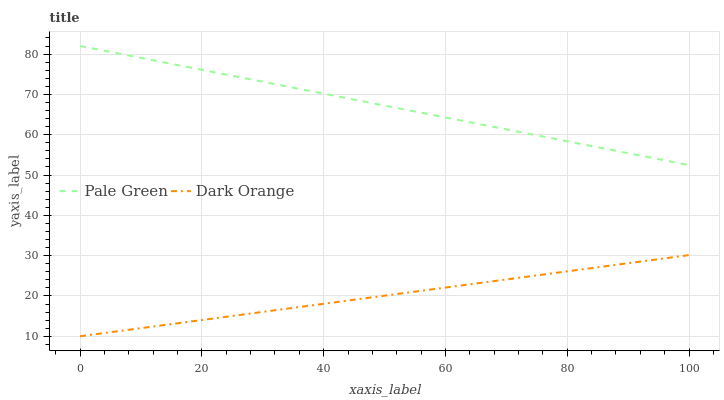Does Dark Orange have the minimum area under the curve?
Answer yes or no. Yes. Does Pale Green have the maximum area under the curve?
Answer yes or no. Yes. Does Pale Green have the minimum area under the curve?
Answer yes or no. No. Is Dark Orange the smoothest?
Answer yes or no. Yes. Is Pale Green the roughest?
Answer yes or no. Yes. Is Pale Green the smoothest?
Answer yes or no. No. Does Dark Orange have the lowest value?
Answer yes or no. Yes. Does Pale Green have the lowest value?
Answer yes or no. No. Does Pale Green have the highest value?
Answer yes or no. Yes. Is Dark Orange less than Pale Green?
Answer yes or no. Yes. Is Pale Green greater than Dark Orange?
Answer yes or no. Yes. Does Dark Orange intersect Pale Green?
Answer yes or no. No. 